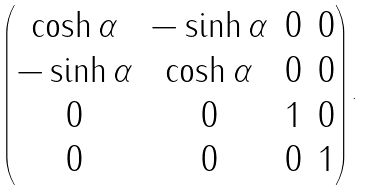<formula> <loc_0><loc_0><loc_500><loc_500>\begin{pmatrix} \cosh \alpha & - \sinh \alpha & 0 & 0 \\ - \sinh \alpha & \cosh \alpha & 0 & 0 \\ 0 & 0 & 1 & 0 \\ 0 & 0 & 0 & 1 \end{pmatrix} .</formula> 